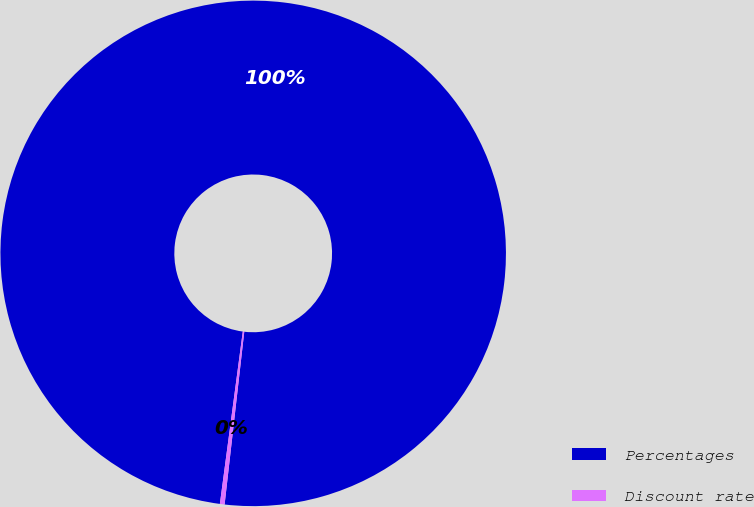<chart> <loc_0><loc_0><loc_500><loc_500><pie_chart><fcel>Percentages<fcel>Discount rate<nl><fcel>99.7%<fcel>0.3%<nl></chart> 